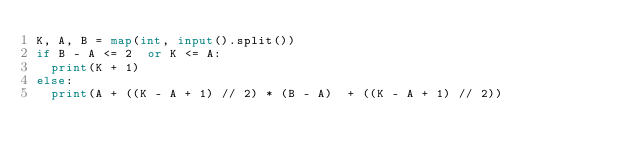Convert code to text. <code><loc_0><loc_0><loc_500><loc_500><_Python_>K, A, B = map(int, input().split())
if B - A <= 2  or K <= A:
  print(K + 1)
else:
  print(A + ((K - A + 1) // 2) * (B - A)  + ((K - A + 1) // 2))</code> 